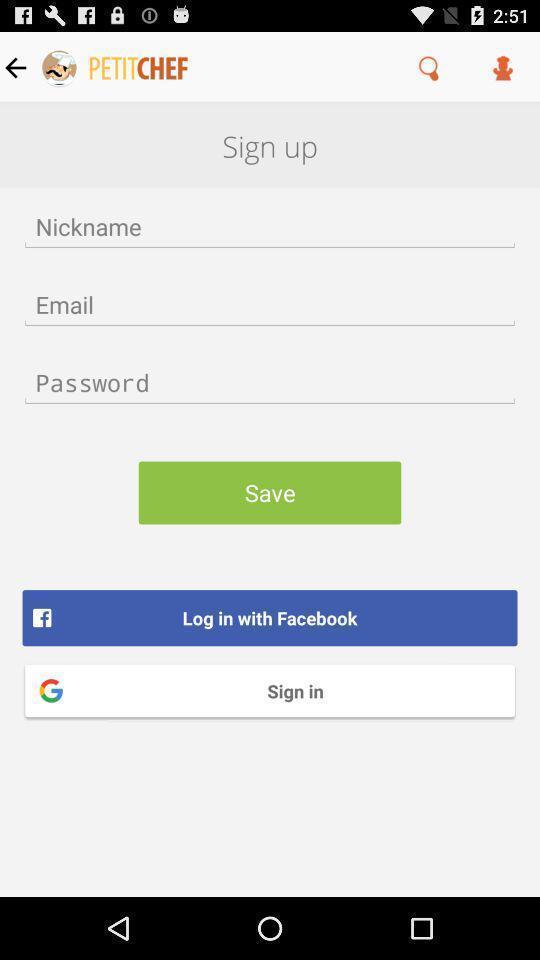Explain what's happening in this screen capture. Screen displaying sign up page. 